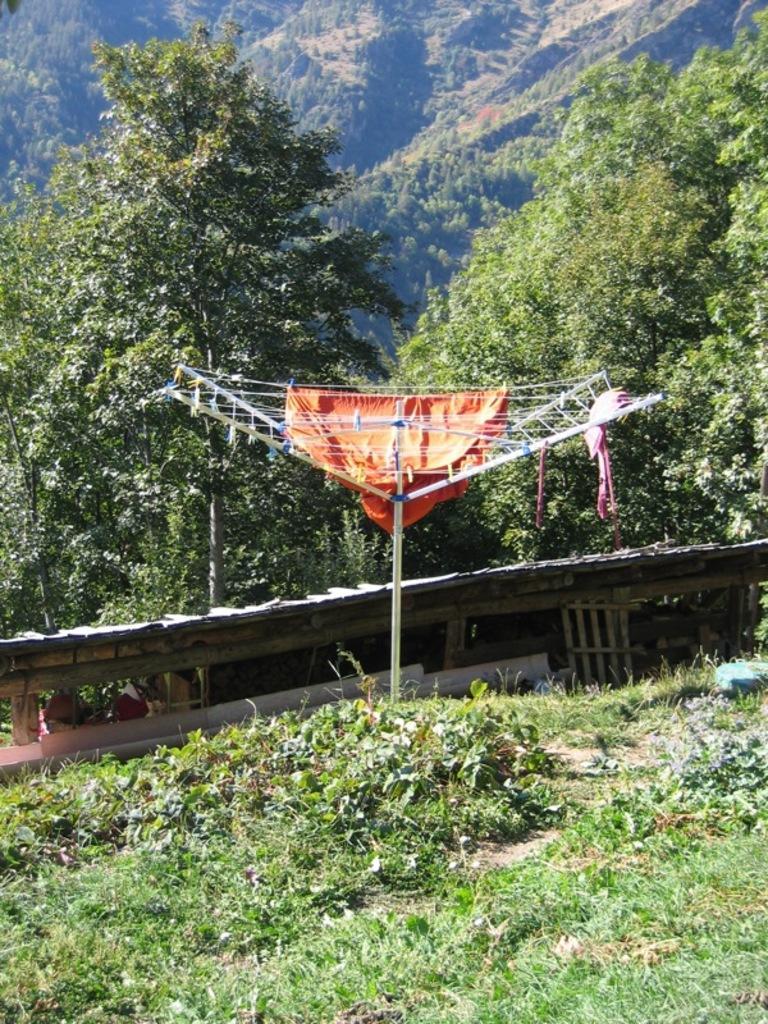How would you summarize this image in a sentence or two? In this picture we can see clothes on a cloth dryer stand, here we can see grass, wooden objects and some objects on the ground and in the background we can see trees. 